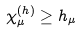<formula> <loc_0><loc_0><loc_500><loc_500>\chi _ { \mu } ^ { ( h ) } \geq h _ { \mu }</formula> 